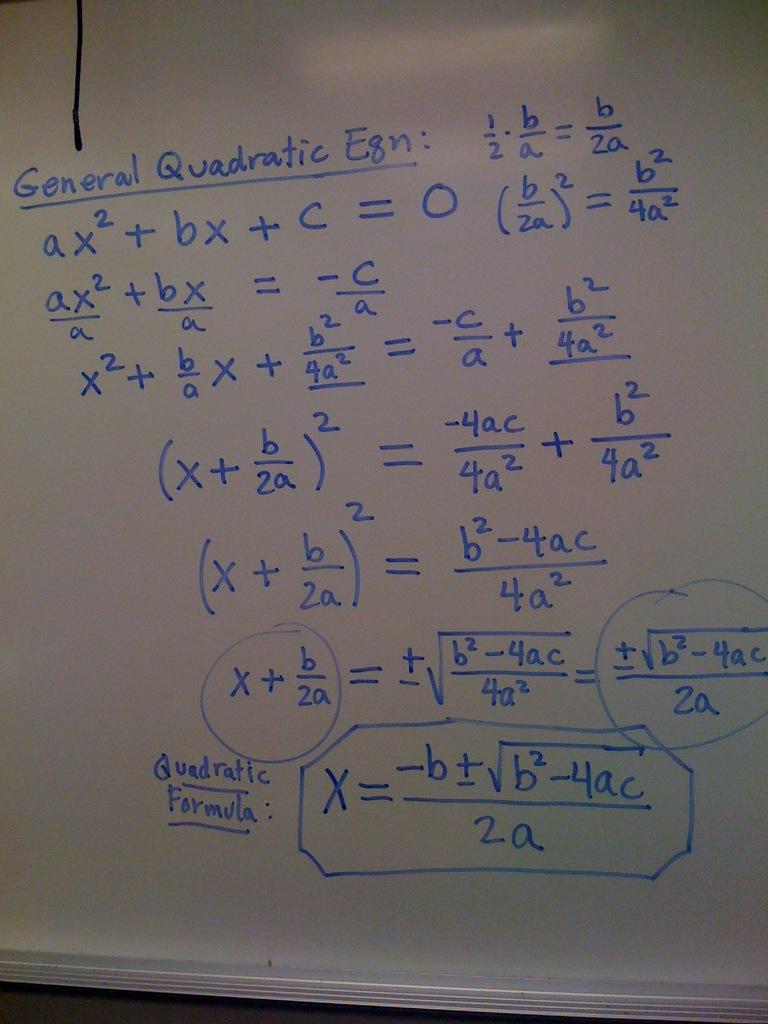What formula is the board explaining?
Provide a short and direct response. General quadratic eqn. What kind of quadratic egn is there?
Keep it short and to the point. General. 